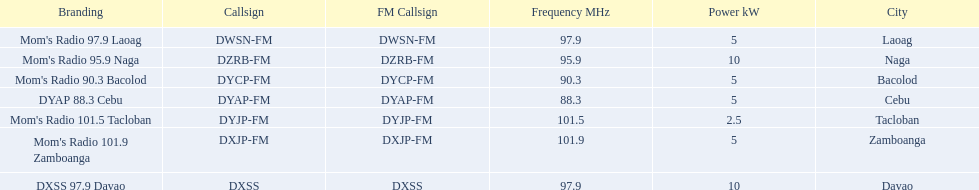Which stations use less than 10kw of power? Mom's Radio 97.9 Laoag, Mom's Radio 90.3 Bacolod, DYAP 88.3 Cebu, Mom's Radio 101.5 Tacloban, Mom's Radio 101.9 Zamboanga. Do any stations use less than 5kw of power? if so, which ones? Mom's Radio 101.5 Tacloban. 